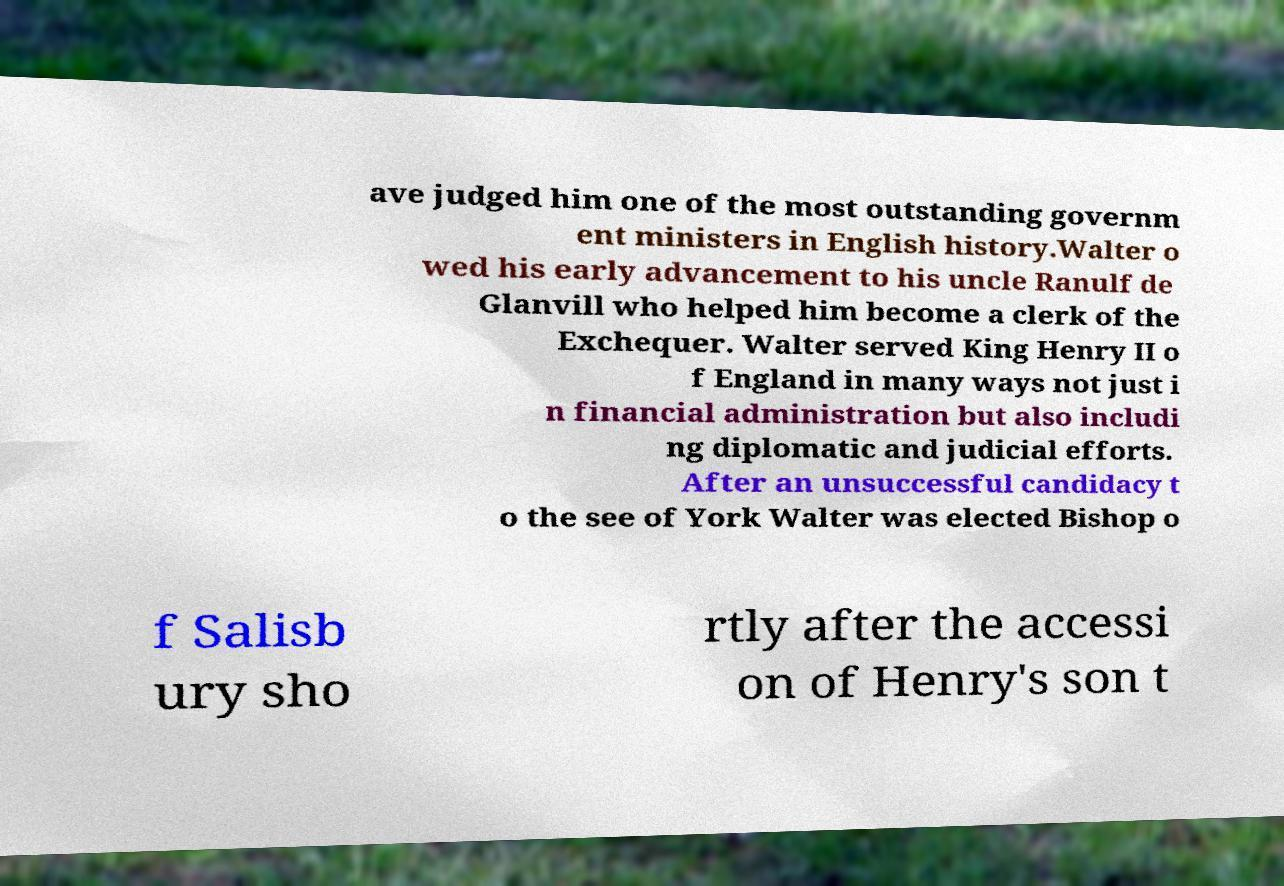Please read and relay the text visible in this image. What does it say? ave judged him one of the most outstanding governm ent ministers in English history.Walter o wed his early advancement to his uncle Ranulf de Glanvill who helped him become a clerk of the Exchequer. Walter served King Henry II o f England in many ways not just i n financial administration but also includi ng diplomatic and judicial efforts. After an unsuccessful candidacy t o the see of York Walter was elected Bishop o f Salisb ury sho rtly after the accessi on of Henry's son t 